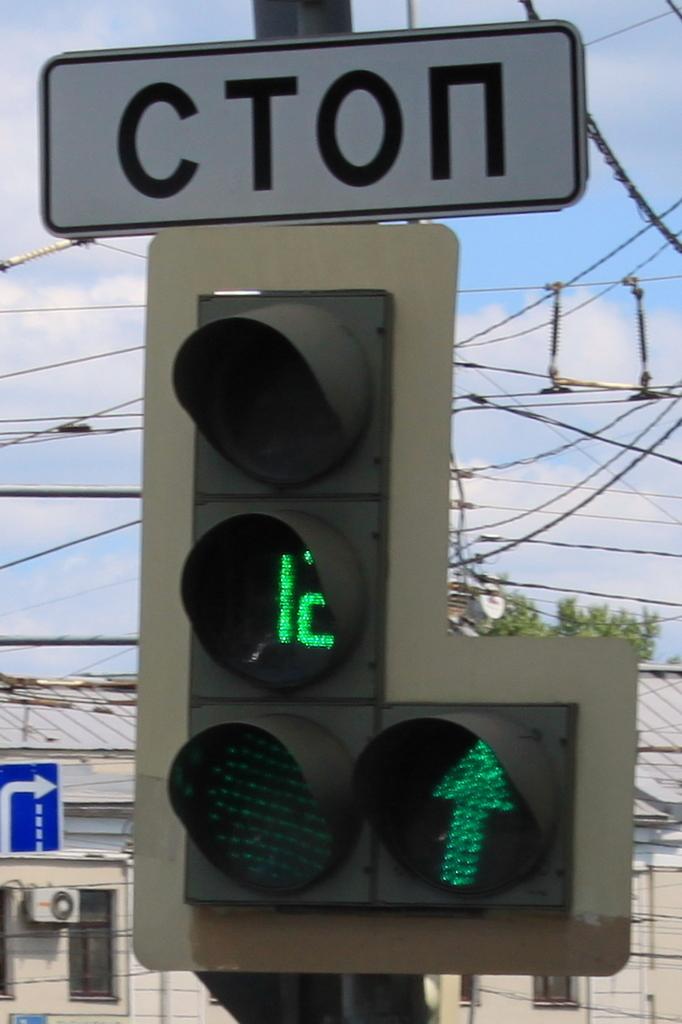How many seconds are left on the green signal?
Provide a short and direct response. 12. 